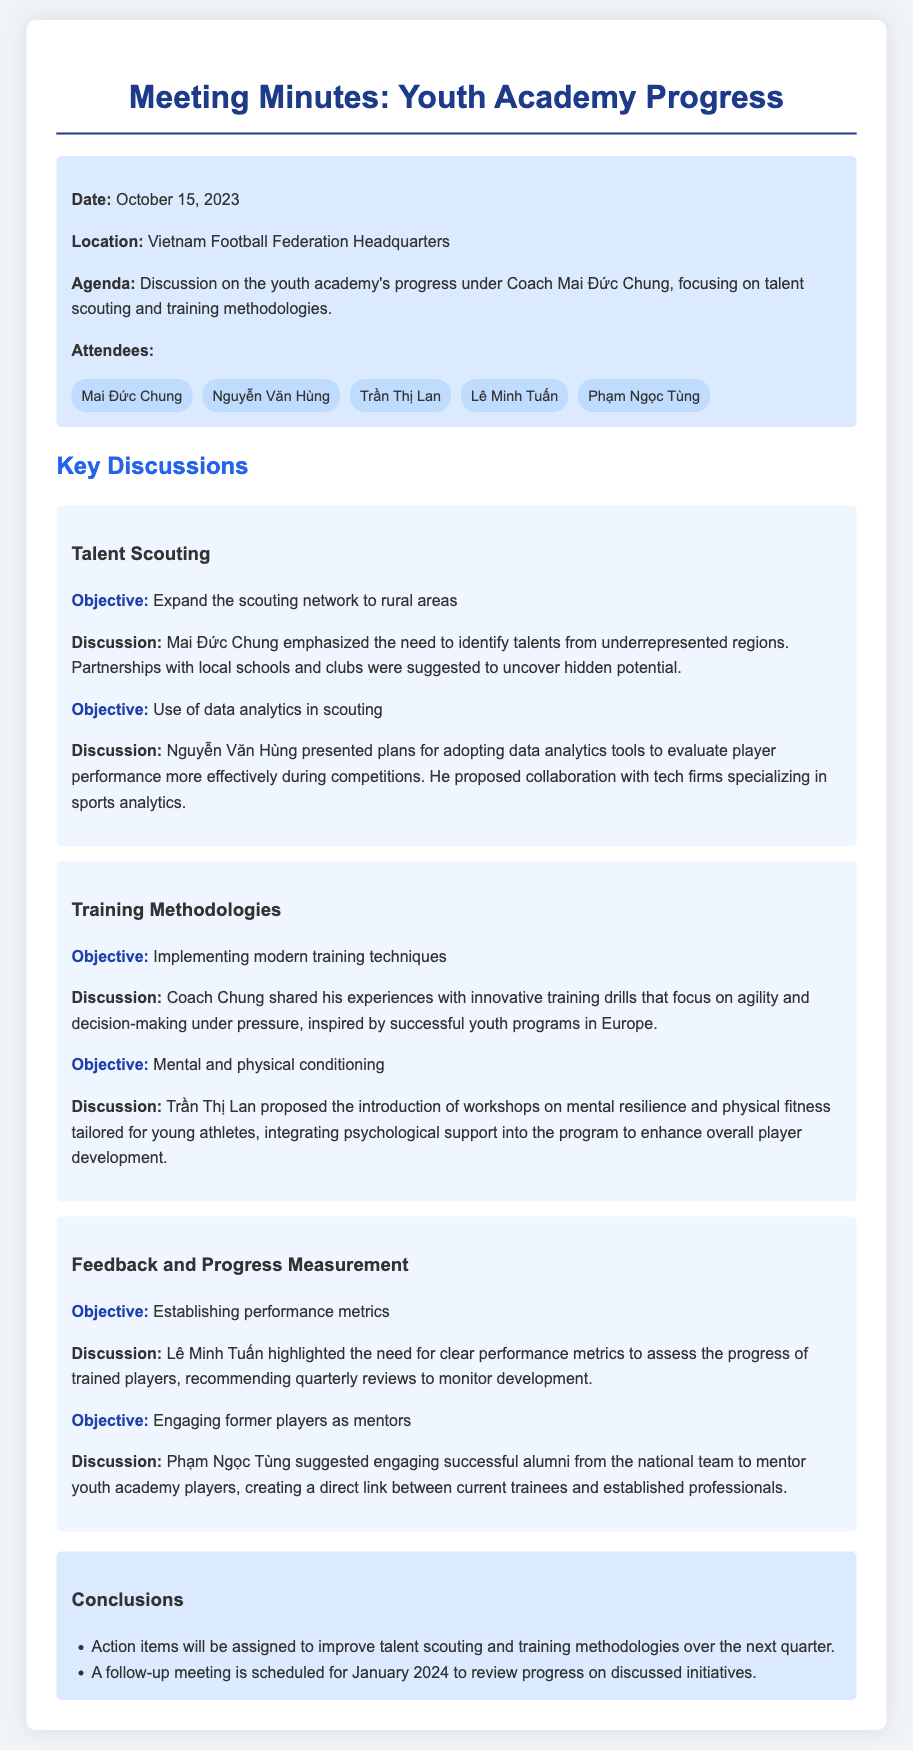What is the date of the meeting? The date of the meeting is explicitly stated at the beginning of the document.
Answer: October 15, 2023 Who suggested engaging former players as mentors? This information is found in the feedback section of the document regarding who made the suggestion to engage former players.
Answer: Phạm Ngọc Tùng What is one proposed method for talent scouting? The document discusses various objectives; one specific method is highlighted for talent scouting.
Answer: Partnerships with local schools and clubs What is the main objective related to training methodologies? The document lists several objectives; the main goal concerning training methodologies is stated.
Answer: Implementing modern training techniques How many attendees were present at the meeting? This information can be found in the attendee section of the document detailing the count of individuals present.
Answer: Five What was emphasized regarding mental resilience? The document mentions a proposal focused on improving player development through psychological support.
Answer: Workshops on mental resilience What are the action items expected to focus on? The conclusions section specifies the primary focus of upcoming action items.
Answer: Talent scouting and training methodologies When is the follow-up meeting scheduled? The follow-up meeting date is explicitly stated in the conclusions section.
Answer: January 2024 